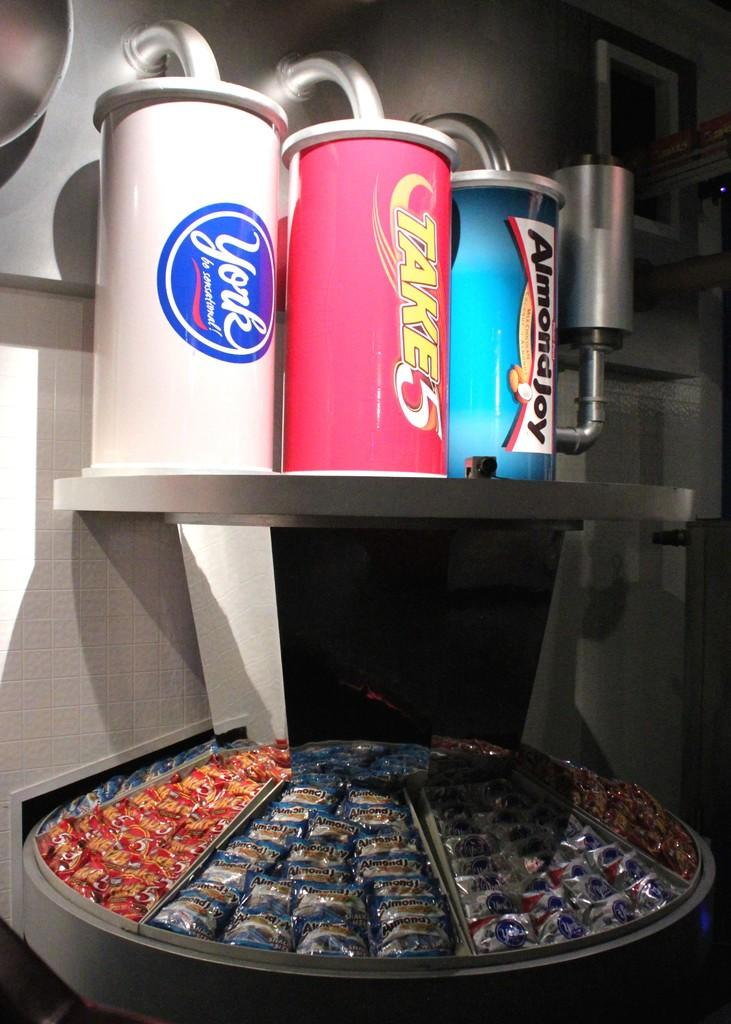<image>
Write a terse but informative summary of the picture. A candy display for Take5 and other types of candy. 